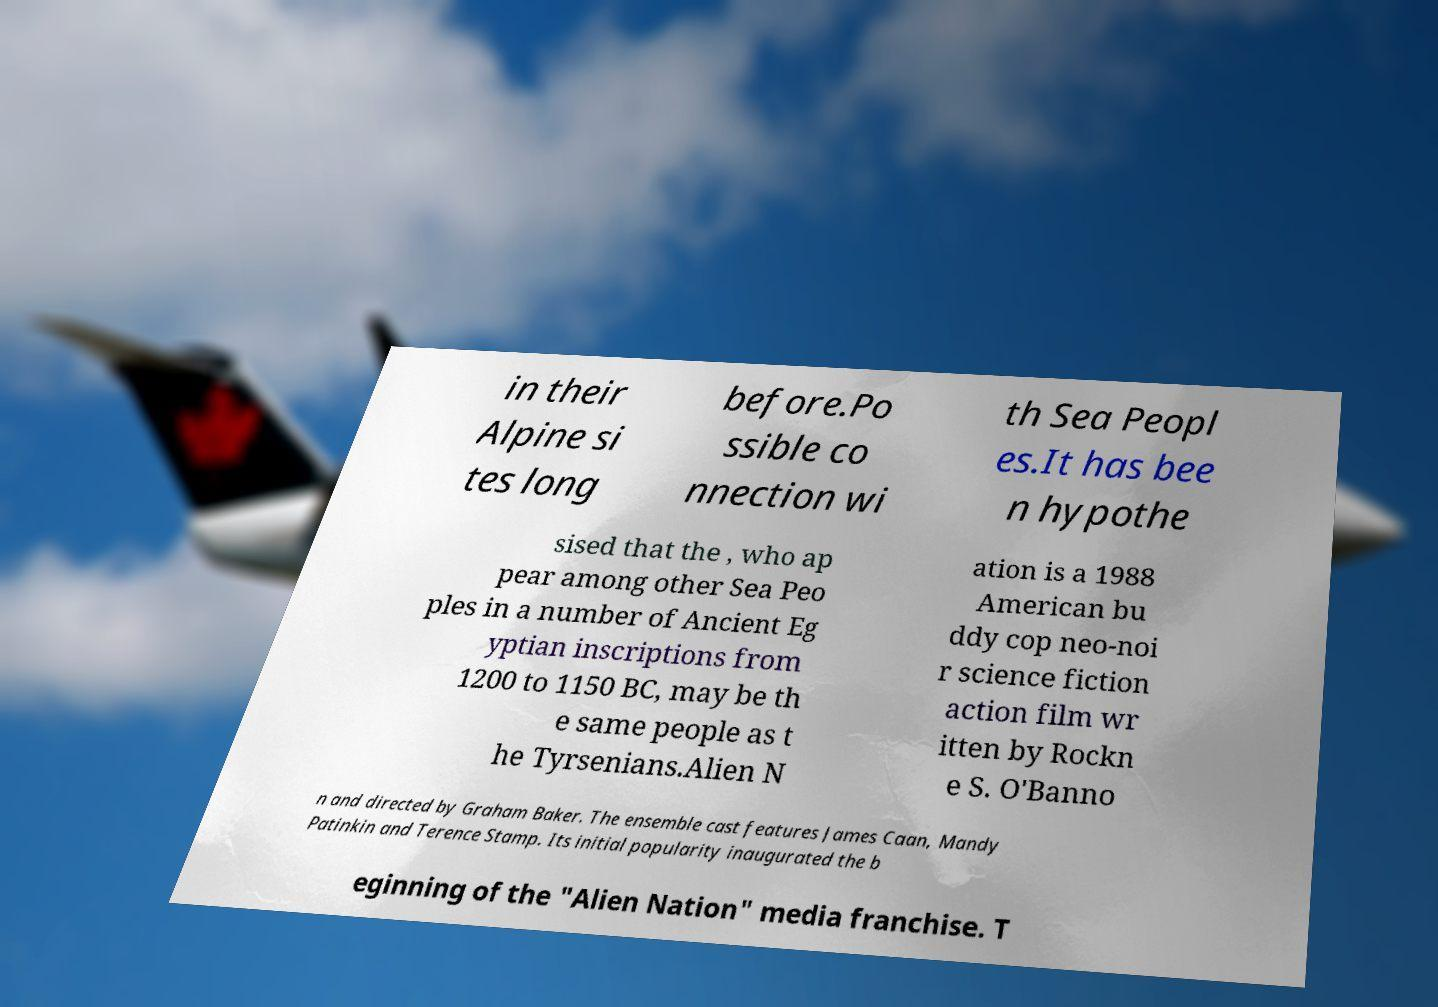What messages or text are displayed in this image? I need them in a readable, typed format. in their Alpine si tes long before.Po ssible co nnection wi th Sea Peopl es.It has bee n hypothe sised that the , who ap pear among other Sea Peo ples in a number of Ancient Eg yptian inscriptions from 1200 to 1150 BC, may be th e same people as t he Tyrsenians.Alien N ation is a 1988 American bu ddy cop neo-noi r science fiction action film wr itten by Rockn e S. O'Banno n and directed by Graham Baker. The ensemble cast features James Caan, Mandy Patinkin and Terence Stamp. Its initial popularity inaugurated the b eginning of the "Alien Nation" media franchise. T 